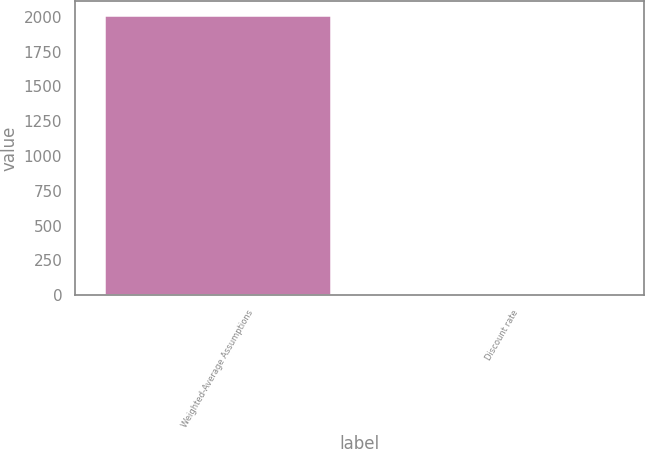<chart> <loc_0><loc_0><loc_500><loc_500><bar_chart><fcel>Weighted-Average Assumptions<fcel>Discount rate<nl><fcel>2015<fcel>4.2<nl></chart> 